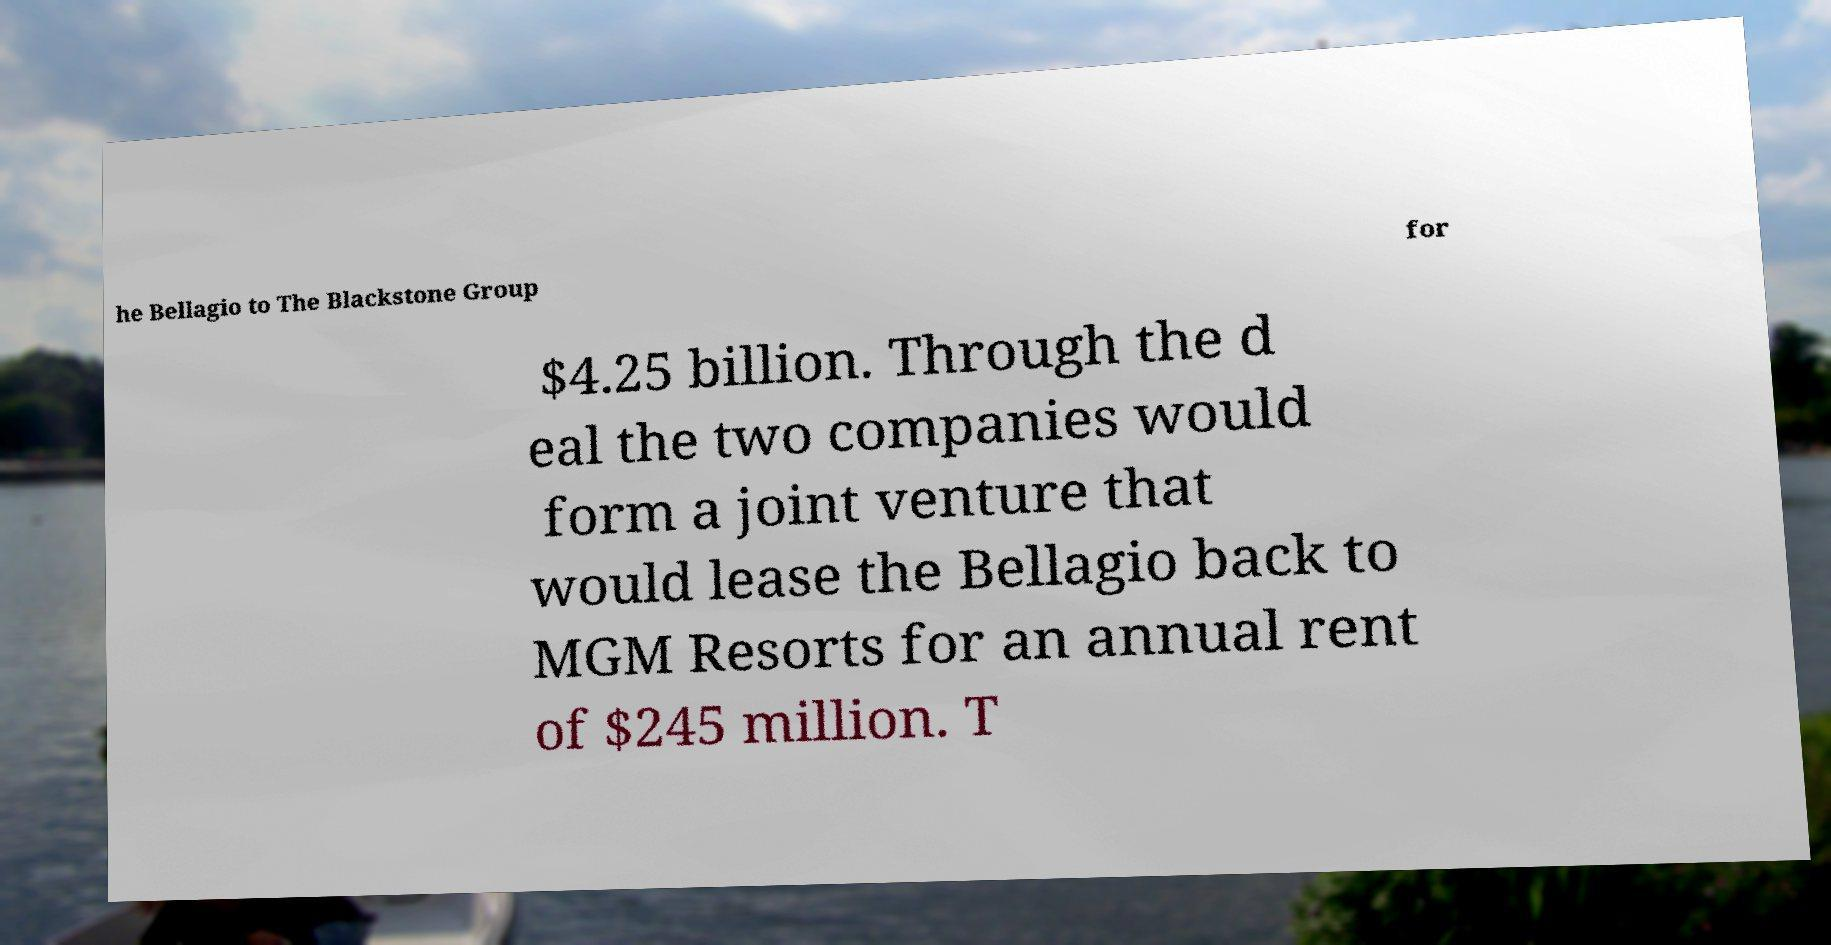Can you read and provide the text displayed in the image?This photo seems to have some interesting text. Can you extract and type it out for me? he Bellagio to The Blackstone Group for $4.25 billion. Through the d eal the two companies would form a joint venture that would lease the Bellagio back to MGM Resorts for an annual rent of $245 million. T 